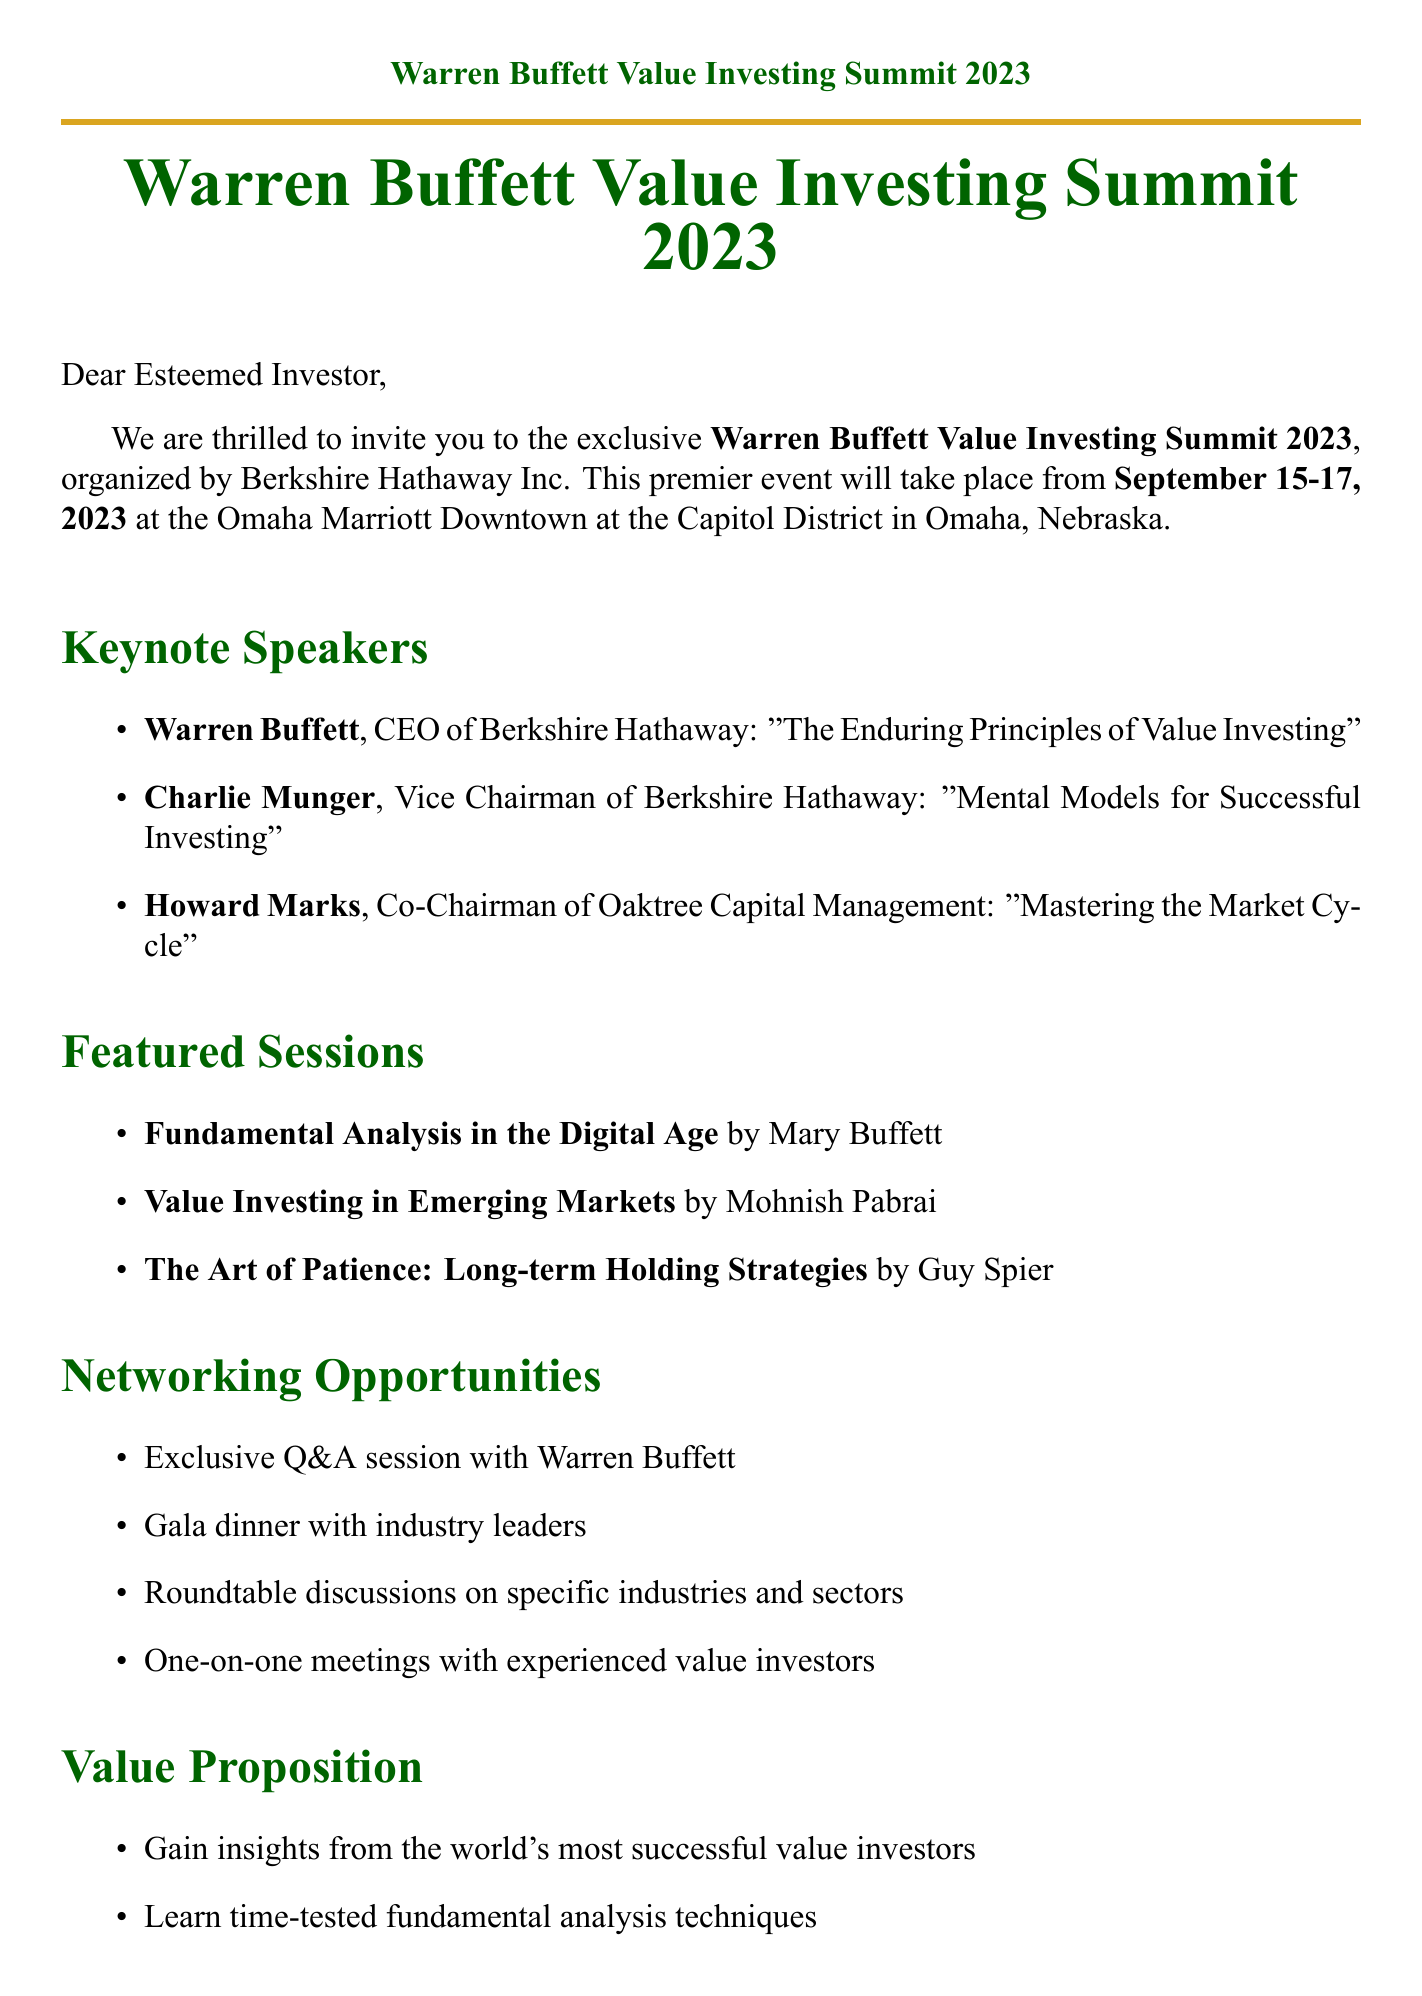What is the name of the event? The name of the event is provided in the document as "Warren Buffett Value Investing Summit 2023."
Answer: Warren Buffett Value Investing Summit 2023 Who is the organizer of the summit? The organizer of the summit is mentioned in the document as "Berkshire Hathaway Inc."
Answer: Berkshire Hathaway Inc What are the dates of the event? The dates of the event can be found in the document, specifically stated as "September 15-17, 2023."
Answer: September 15-17, 2023 Who is speaking about mental models for investing? The document specifies that Charlie Munger is discussing "Mental Models for Successful Investing."
Answer: Charlie Munger What is the early bird registration price? The early bird registration price is provided in the document as "$2,500."
Answer: $2,500 What is included in the value proposition? The value proposition includes multiple items, one being "Gain insights from the world's most successful value investors."
Answer: Gain insights from the world's most successful value investors How many keynote speakers are listed? The document includes a section for keynote speakers that lists three individuals.
Answer: Three What is one of the networking opportunities at the summit? The document provides various networking opportunities, one being "Exclusive Q&A session with Warren Buffett."
Answer: Exclusive Q&A session with Warren Buffett Who provided a testimonial recommending the conference? The document includes testimonials, one from John Bogle recommending the conference.
Answer: John Bogle 